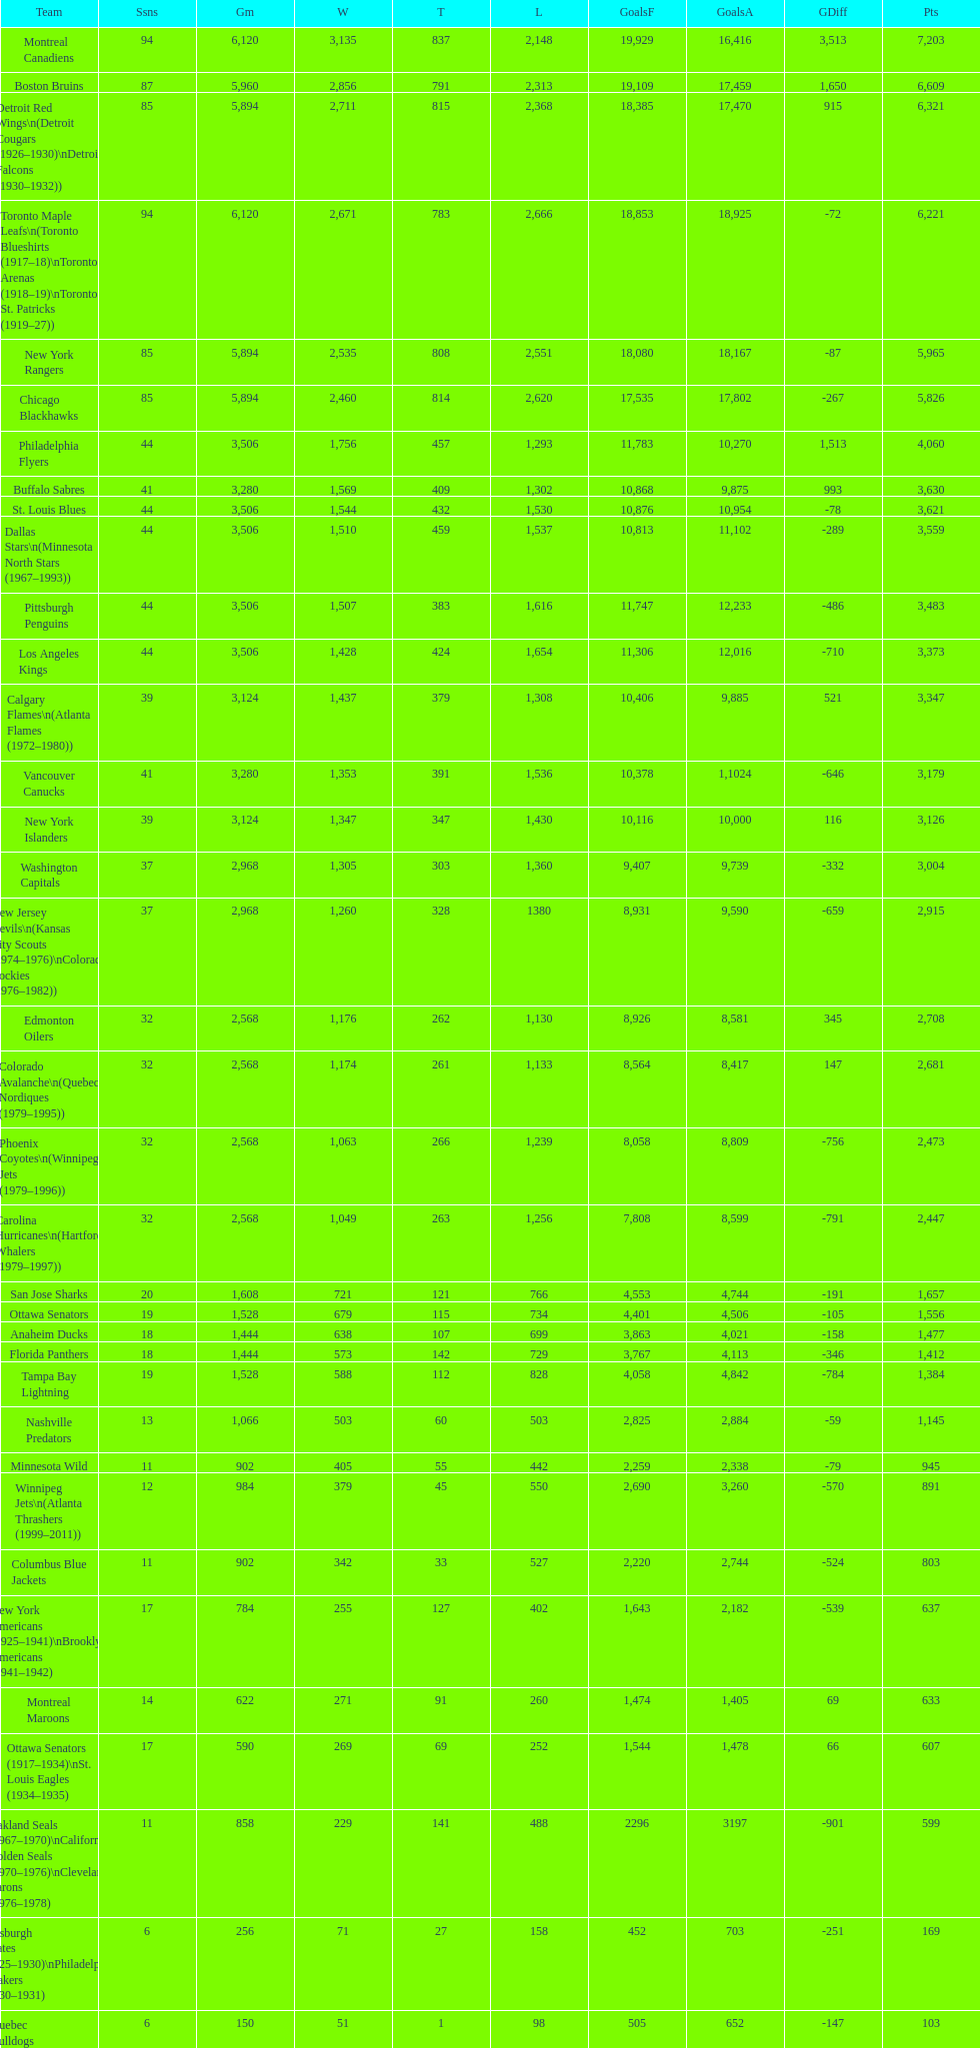How many total points has the lost angeles kings scored? 3,373. 